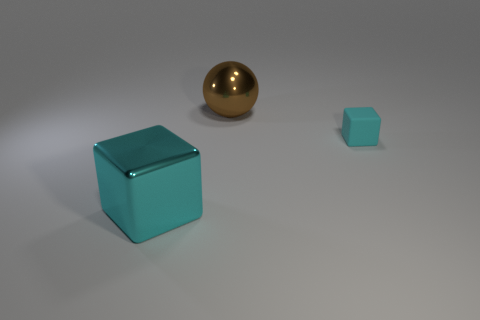Add 2 small green balls. How many objects exist? 5 Subtract 1 cubes. How many cubes are left? 1 Subtract all cubes. How many objects are left? 1 Subtract all large shiny cylinders. Subtract all large metallic things. How many objects are left? 1 Add 3 small rubber things. How many small rubber things are left? 4 Add 3 tiny cyan blocks. How many tiny cyan blocks exist? 4 Subtract 0 brown cylinders. How many objects are left? 3 Subtract all red cubes. Subtract all yellow cylinders. How many cubes are left? 2 Subtract all purple cubes. How many red balls are left? 0 